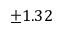Convert formula to latex. <formula><loc_0><loc_0><loc_500><loc_500>\pm 1 . 3 2 \</formula> 